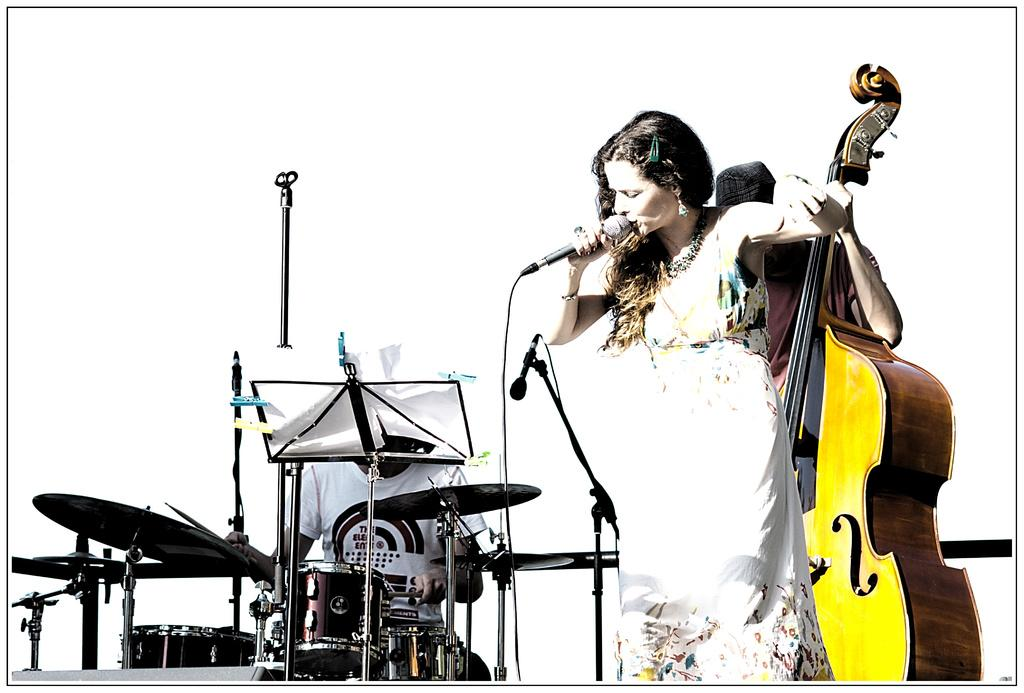Who is the main subject in the image? There is a woman in the image. What is the woman holding in the image? The woman is holding a mic. Can you describe the people in the background of the image? There are two persons in the background of the image, and they are holding musical instruments. What type of arithmetic problem is the woman solving on the floor in the image? There is no arithmetic problem or floor visible in the image; the woman is holding a mic and there are two persons in the background holding musical instruments. 